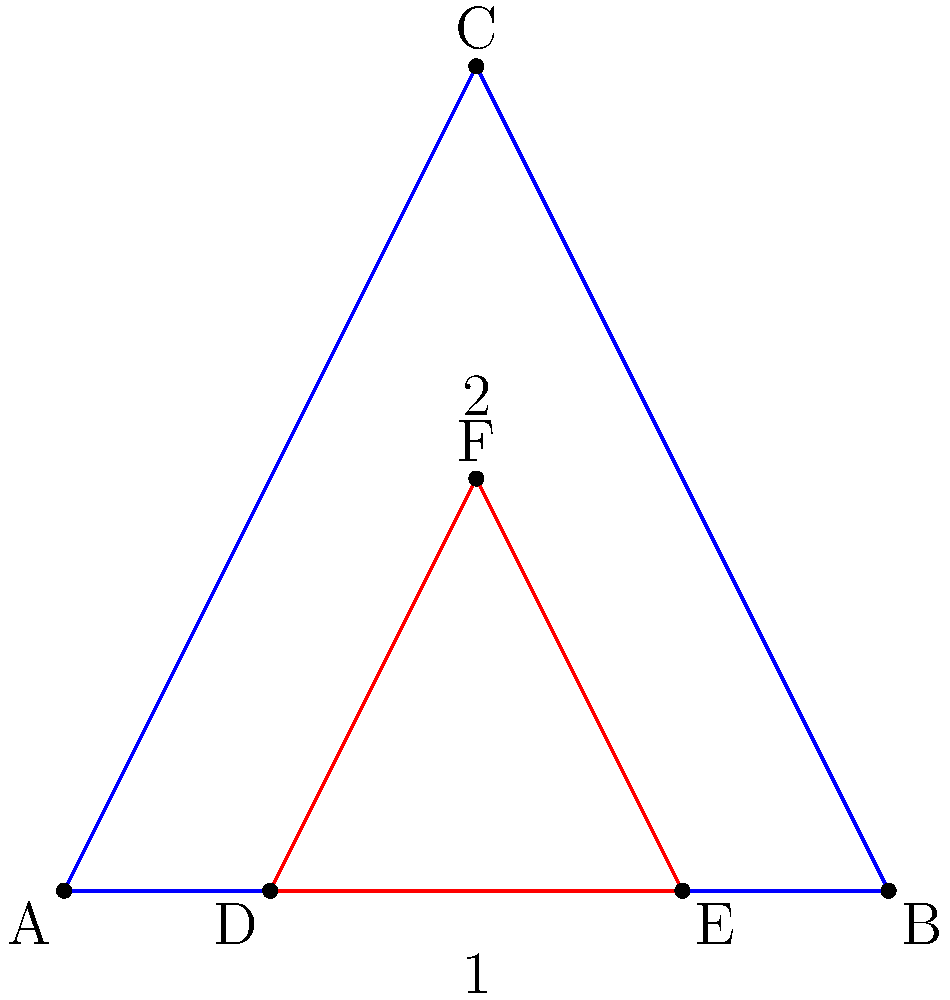Consider two triangular heat shield designs for a Mars-bound spacecraft, as shown in the figure. Triangle 1 (ABC) is an isosceles triangle with a base of 2 units and a height of 2 units. Triangle 2 (DEF) is an equilateral triangle with a side length of 1 unit. Which shape would be more effective in minimizing drag and heat buildup during atmospheric entry on Mars, assuming both have the same surface area? To determine which shape would be more effective, we need to consider both drag and heat buildup:

1. Drag minimization:
   - A more streamlined shape reduces drag.
   - Triangle 2 (DEF) has a sharper apex angle, which creates less frontal area and thus less drag.

2. Heat buildup:
   - Heat buildup is related to the surface area exposed to the incoming flow.
   - Both triangles have the same surface area (given in the question).

3. Shock wave formation:
   - A sharper leading edge creates a weaker shock wave, reducing overall heating.
   - Triangle 2 (DEF) has a sharper apex, which would create a weaker shock wave.

4. Flow separation:
   - Smoother contours delay flow separation, reducing turbulence and heating.
   - Triangle 1 (ABC) has a gentler slope, which may delay flow separation compared to Triangle 2.

5. Stability:
   - A wider base provides more stability during entry.
   - Triangle 1 (ABC) has a wider base, offering better stability.

6. Heat distribution:
   - A more uniform heat distribution is desirable to prevent localized hot spots.
   - Triangle 1 (ABC) may allow for more even heat distribution due to its gentler contours.

Considering these factors, Triangle 2 (DEF) would be more effective in minimizing drag due to its sharper apex and reduced frontal area. It would also create a weaker shock wave, potentially reducing overall heating. However, Triangle 1 (ABC) may offer better stability and more even heat distribution.

In the context of Mars atmospheric entry, where the atmosphere is much thinner than Earth's, minimizing drag becomes relatively less critical compared to managing heat buildup and maintaining stability. Therefore, the more gradual slope and wider base of Triangle 1 (ABC) would likely be more beneficial overall.
Answer: Triangle 1 (ABC) 